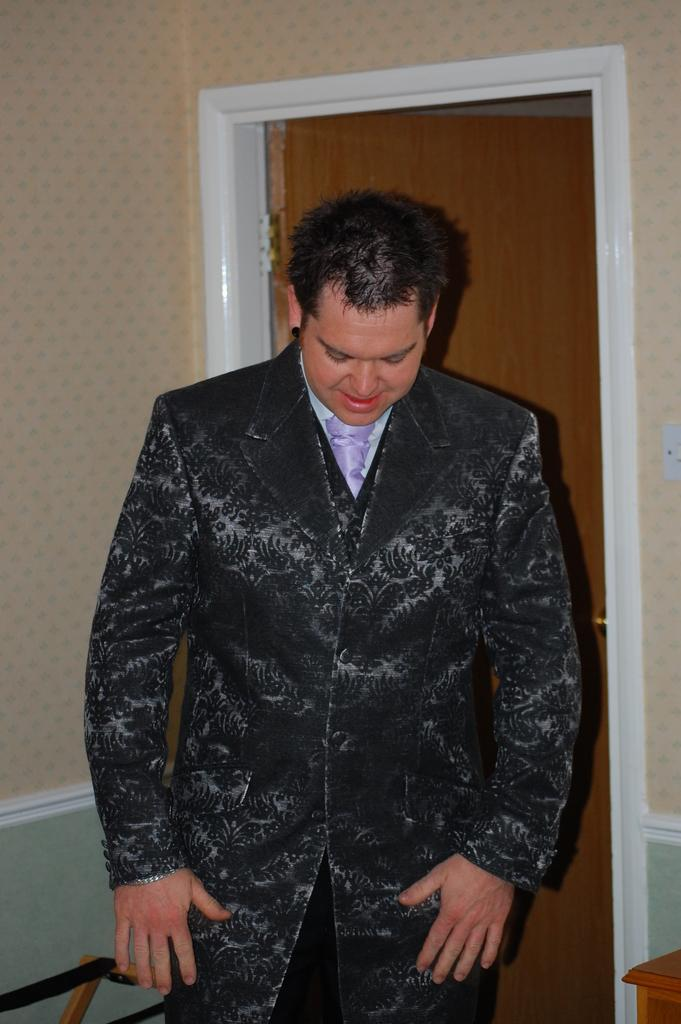What is the main subject of the image? There is a man standing in the image. Where is the man located in the image? The man is standing on the floor. What can be seen in the background of the image? There are walls and doors in the background of the image. How much salt is present on the man's clothing in the image? There is no salt present on the man's clothing in the image. What route is the man taking in the image? The image does not show the man taking any route, as he is standing still. 